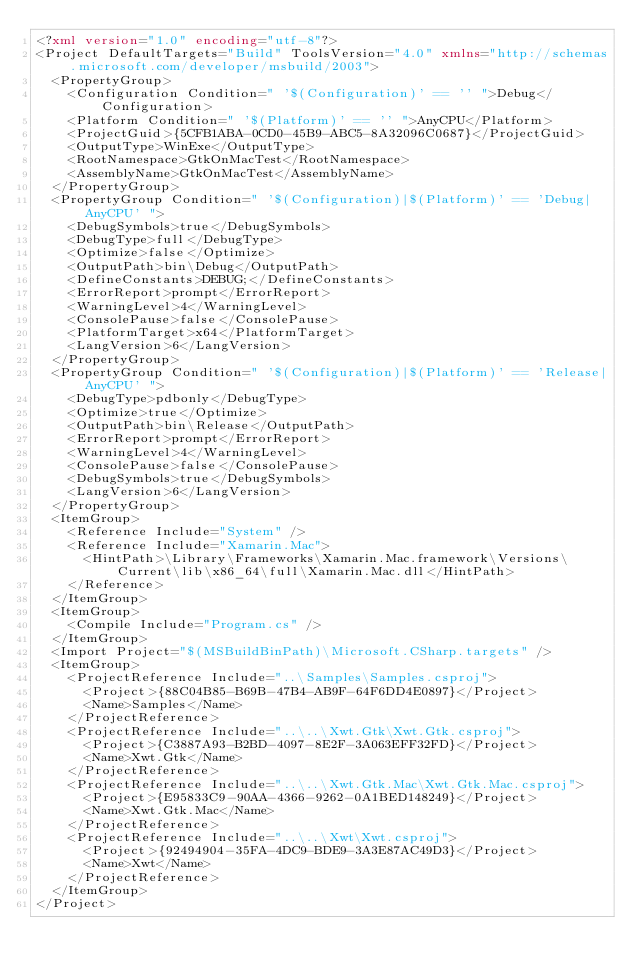Convert code to text. <code><loc_0><loc_0><loc_500><loc_500><_XML_><?xml version="1.0" encoding="utf-8"?>
<Project DefaultTargets="Build" ToolsVersion="4.0" xmlns="http://schemas.microsoft.com/developer/msbuild/2003">
  <PropertyGroup>
    <Configuration Condition=" '$(Configuration)' == '' ">Debug</Configuration>
    <Platform Condition=" '$(Platform)' == '' ">AnyCPU</Platform>
    <ProjectGuid>{5CFB1ABA-0CD0-45B9-ABC5-8A32096C0687}</ProjectGuid>
    <OutputType>WinExe</OutputType>
    <RootNamespace>GtkOnMacTest</RootNamespace>
    <AssemblyName>GtkOnMacTest</AssemblyName>
  </PropertyGroup>
  <PropertyGroup Condition=" '$(Configuration)|$(Platform)' == 'Debug|AnyCPU' ">
    <DebugSymbols>true</DebugSymbols>
    <DebugType>full</DebugType>
    <Optimize>false</Optimize>
    <OutputPath>bin\Debug</OutputPath>
    <DefineConstants>DEBUG;</DefineConstants>
    <ErrorReport>prompt</ErrorReport>
    <WarningLevel>4</WarningLevel>
    <ConsolePause>false</ConsolePause>
    <PlatformTarget>x64</PlatformTarget>
    <LangVersion>6</LangVersion>
  </PropertyGroup>
  <PropertyGroup Condition=" '$(Configuration)|$(Platform)' == 'Release|AnyCPU' ">
    <DebugType>pdbonly</DebugType>
    <Optimize>true</Optimize>
    <OutputPath>bin\Release</OutputPath>
    <ErrorReport>prompt</ErrorReport>
    <WarningLevel>4</WarningLevel>
    <ConsolePause>false</ConsolePause>
    <DebugSymbols>true</DebugSymbols>
    <LangVersion>6</LangVersion>
  </PropertyGroup>
  <ItemGroup>
    <Reference Include="System" />
    <Reference Include="Xamarin.Mac">
      <HintPath>\Library\Frameworks\Xamarin.Mac.framework\Versions\Current\lib\x86_64\full\Xamarin.Mac.dll</HintPath>
    </Reference>
  </ItemGroup>
  <ItemGroup>
    <Compile Include="Program.cs" />
  </ItemGroup>
  <Import Project="$(MSBuildBinPath)\Microsoft.CSharp.targets" />
  <ItemGroup>
    <ProjectReference Include="..\Samples\Samples.csproj">
      <Project>{88C04B85-B69B-47B4-AB9F-64F6DD4E0897}</Project>
      <Name>Samples</Name>
    </ProjectReference>
    <ProjectReference Include="..\..\Xwt.Gtk\Xwt.Gtk.csproj">
      <Project>{C3887A93-B2BD-4097-8E2F-3A063EFF32FD}</Project>
      <Name>Xwt.Gtk</Name>
    </ProjectReference>
    <ProjectReference Include="..\..\Xwt.Gtk.Mac\Xwt.Gtk.Mac.csproj">
      <Project>{E95833C9-90AA-4366-9262-0A1BED148249}</Project>
      <Name>Xwt.Gtk.Mac</Name>
    </ProjectReference>
    <ProjectReference Include="..\..\Xwt\Xwt.csproj">
      <Project>{92494904-35FA-4DC9-BDE9-3A3E87AC49D3}</Project>
      <Name>Xwt</Name>
    </ProjectReference>
  </ItemGroup>
</Project>
</code> 